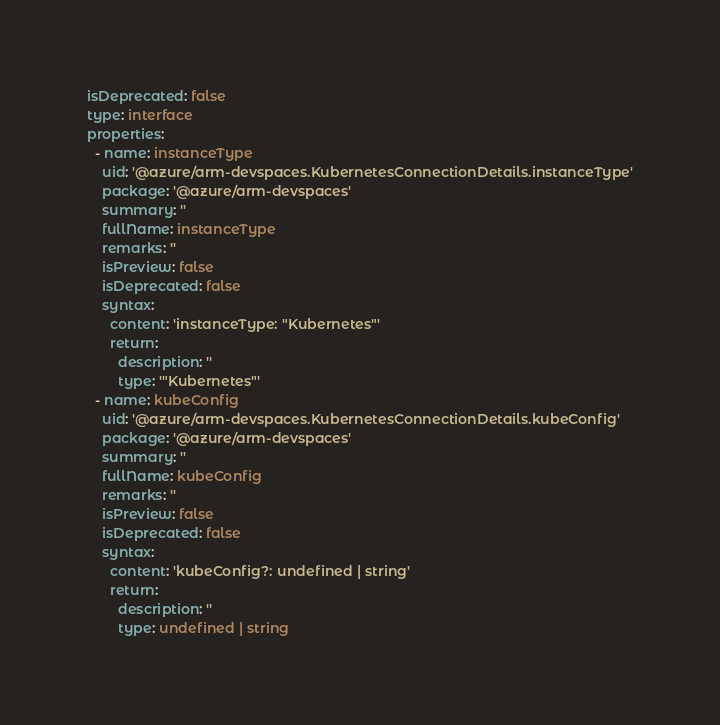<code> <loc_0><loc_0><loc_500><loc_500><_YAML_>isDeprecated: false
type: interface
properties:
  - name: instanceType
    uid: '@azure/arm-devspaces.KubernetesConnectionDetails.instanceType'
    package: '@azure/arm-devspaces'
    summary: ''
    fullName: instanceType
    remarks: ''
    isPreview: false
    isDeprecated: false
    syntax:
      content: 'instanceType: "Kubernetes"'
      return:
        description: ''
        type: '"Kubernetes"'
  - name: kubeConfig
    uid: '@azure/arm-devspaces.KubernetesConnectionDetails.kubeConfig'
    package: '@azure/arm-devspaces'
    summary: ''
    fullName: kubeConfig
    remarks: ''
    isPreview: false
    isDeprecated: false
    syntax:
      content: 'kubeConfig?: undefined | string'
      return:
        description: ''
        type: undefined | string
</code> 